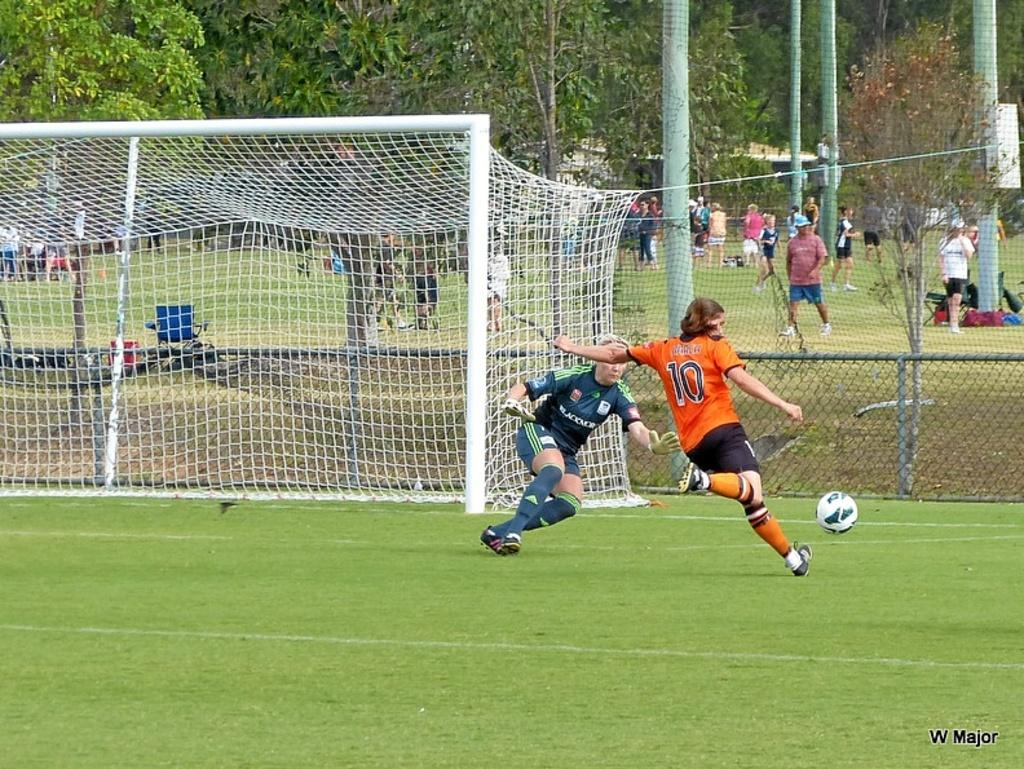<image>
Relay a brief, clear account of the picture shown. Player number 10 has the soccer ball and is moving toward the goal. 